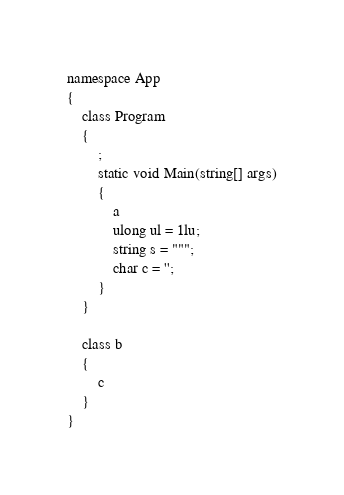Convert code to text. <code><loc_0><loc_0><loc_500><loc_500><_C#_>namespace App
{
    class Program
    {
        ;
        static void Main(string[] args)
        {
            a
            ulong ul = 1lu;
            string s = """;
            char c = '';
        }
    }

    class b
    {
        c
    }
}</code> 